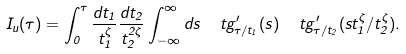Convert formula to latex. <formula><loc_0><loc_0><loc_500><loc_500>I _ { u } ( \tau ) = \int _ { 0 } ^ { \tau } \frac { d t _ { 1 } } { t _ { 1 } ^ { \zeta } } \frac { d t _ { 2 } } { t _ { 2 } ^ { 2 \zeta } } \int _ { - \infty } ^ { \infty } d s \ \ t g ^ { \prime } _ { \tau / t _ { 1 } } ( s ) \ \ t g ^ { \prime } _ { \tau / t _ { 2 } } ( s t _ { 1 } ^ { \zeta } / t _ { 2 } ^ { \zeta } ) .</formula> 